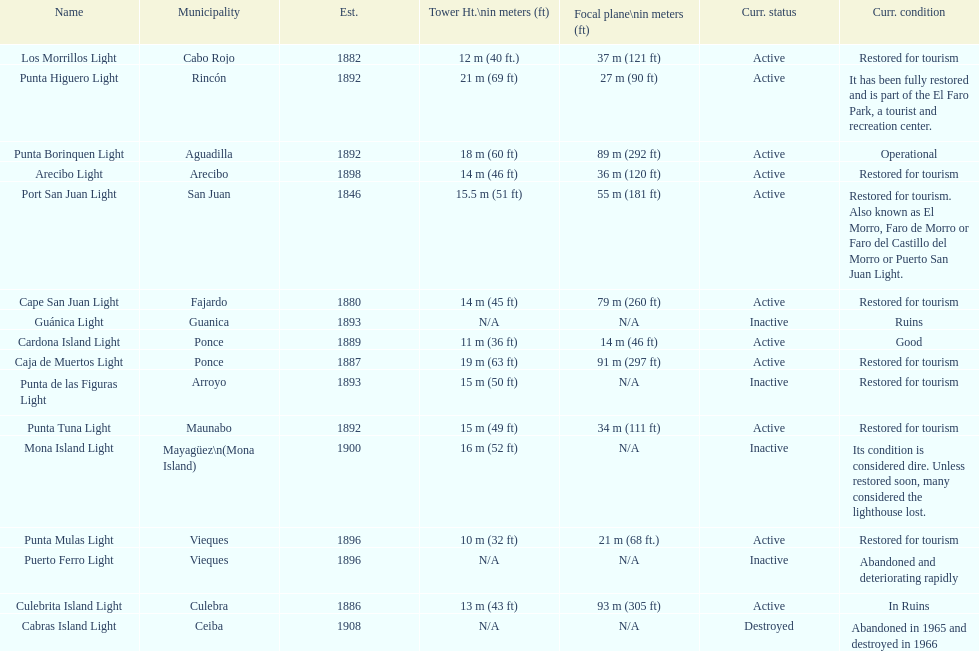Names of municipalities established before 1880 San Juan. 